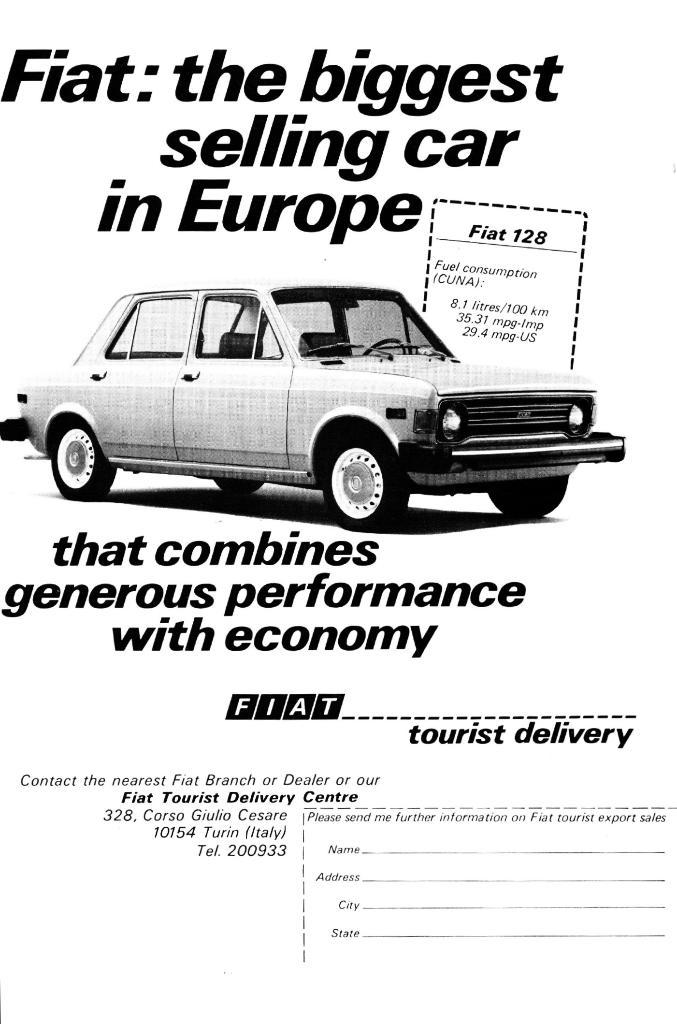What is featured on the poster in the image? There is a poster in the image, and it contains an image of a car. What else can be seen on the poster besides the image of the car? There is text on the poster. What type of scent can be smelled coming from the poster in the image? There is no scent associated with the poster in the image. What type of food is being advertised on the poster in the image? The poster in the image does not advertise any type of food. What type of house is shown in the image? There is no house shown in the image; it features a poster with an image of a car and text. 